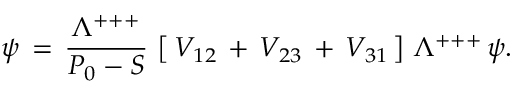Convert formula to latex. <formula><loc_0><loc_0><loc_500><loc_500>\psi \, = \, { \frac { \Lambda ^ { + + + } } { P _ { 0 } - S } } \, \left [ \, V _ { 1 2 } \, + \, V _ { 2 3 } \, + \, V _ { 3 1 } \, \right ] \, \Lambda ^ { + + + } \, \psi .</formula> 